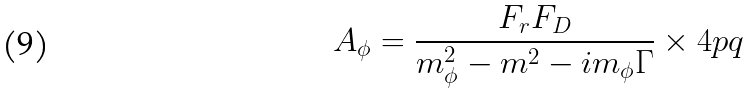Convert formula to latex. <formula><loc_0><loc_0><loc_500><loc_500>A _ { \phi } = \frac { F _ { r } F _ { D } } { m _ { \phi } ^ { 2 } - m ^ { 2 } - i m _ { \phi } \Gamma } \times 4 p q</formula> 